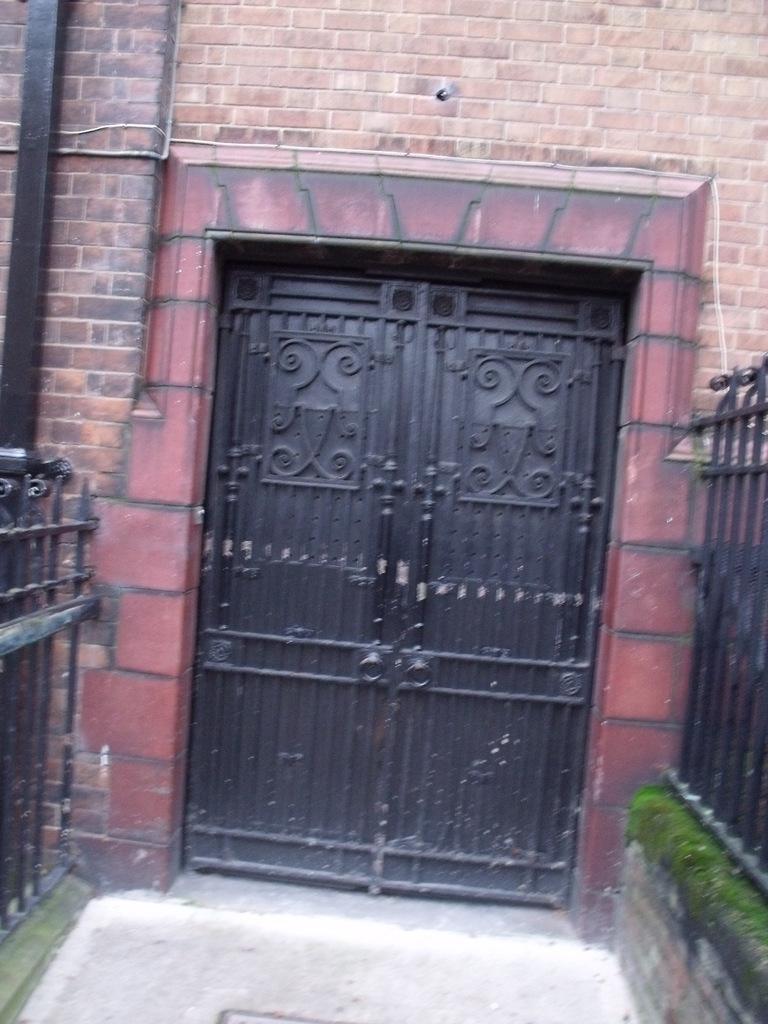Could you give a brief overview of what you see in this image? This image consists of a door in the middle. It is in black color. There is an iron railing on the left side and right side. 